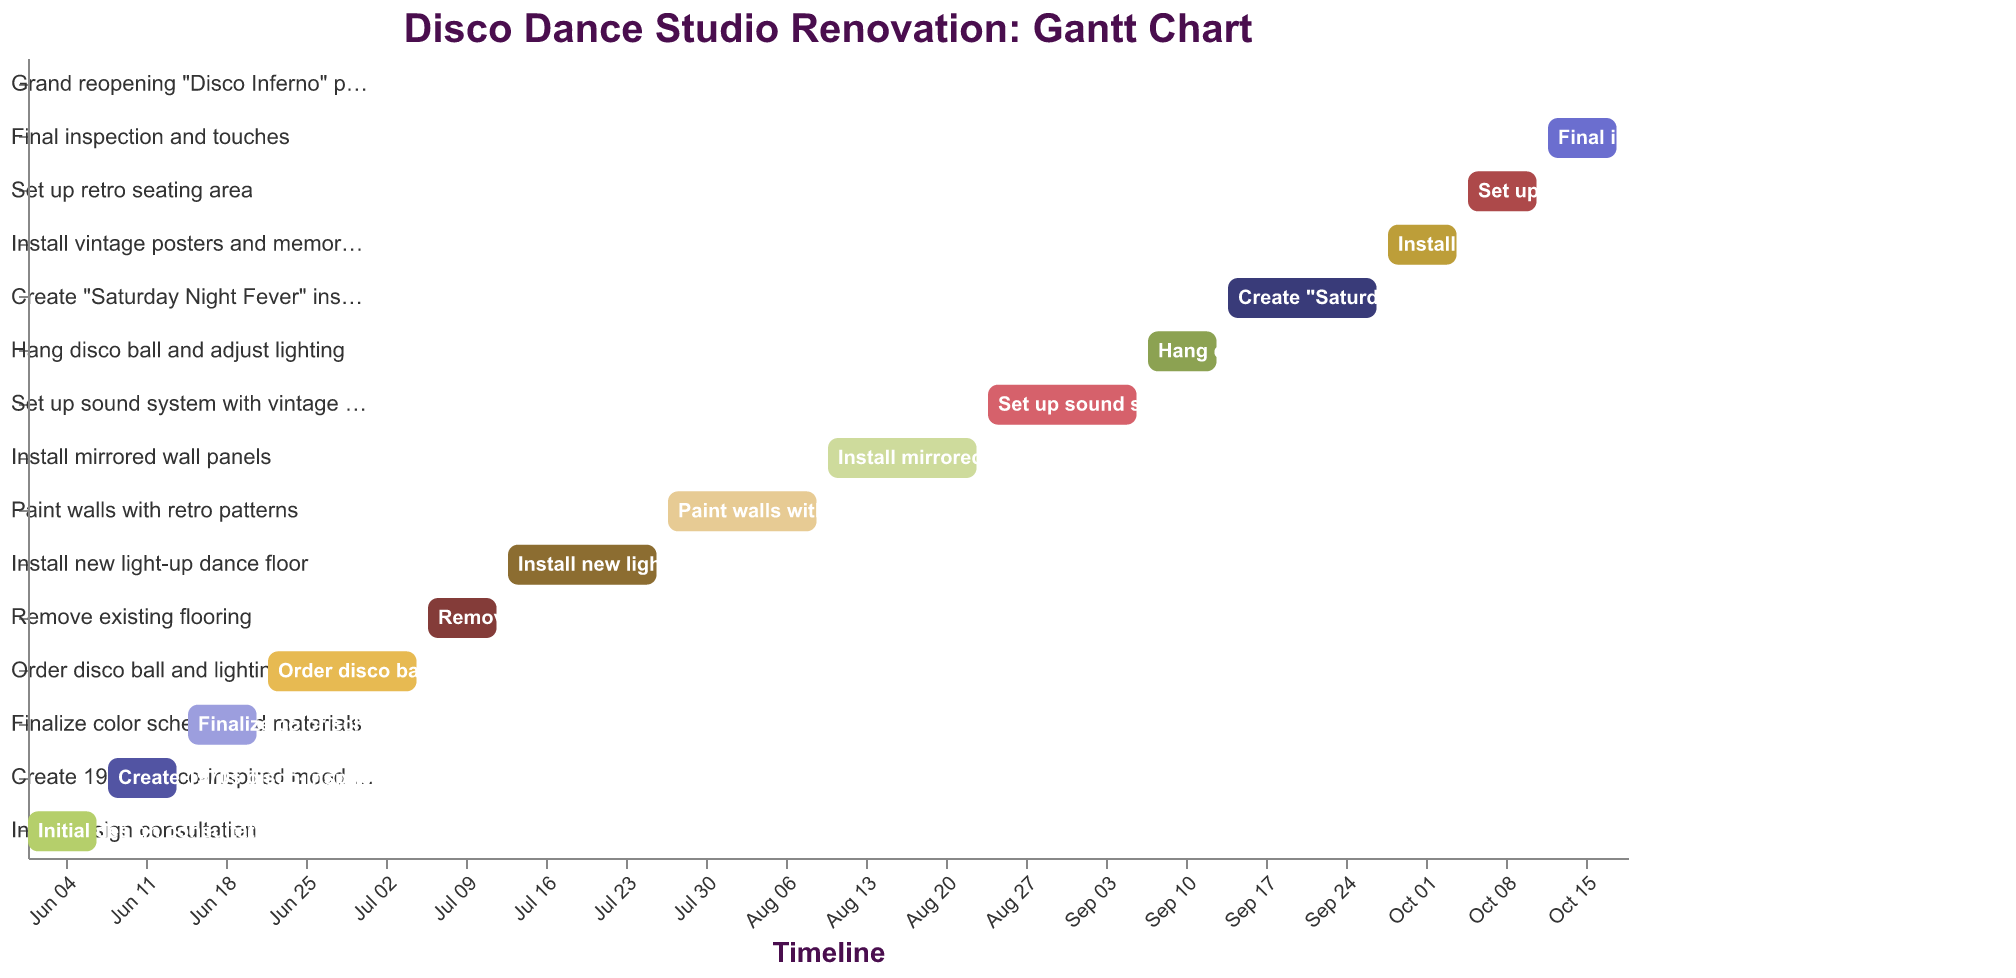What is the title of the Gantt Chart? The title is usually located at the top of the figure. In this chart, the title is prominently displayed and reads "Disco Dance Studio Renovation: Gantt Chart".
Answer: Disco Dance Studio Renovation: Gantt Chart What is the duration of the task "Install new light-up dance floor"? The duration is indicated in the "Duration (days)" column. For "Install new light-up dance floor," it is shown as 14 days.
Answer: 14 days Which task starts immediately after the "Order disco ball and lighting equipment" task? By looking at the timeline and the sequence of tasks, the next task that starts after "Order disco ball and lighting equipment" is "Remove existing flooring," which starts on 2023-07-06.
Answer: Remove existing flooring How long does the entire renovation project take, from the initial design consultation to the grand reopening party? The project starts on 2023-06-01 and ends on 2023-10-19. Counting the days between these dates, the entire project lasts 140 days.
Answer: 140 days Which task has the shortest duration? The "Grand reopening 'Disco Inferno' party" has the shortest duration of just 1 day. The start and end date for this task are the same, indicating it lasts only one day.
Answer: Grand reopening "Disco Inferno" party How many tasks have a duration of 7 days? Reviewing the duration for each task, 7 tasks have a duration of 7 days: "Initial design consultation," "Create 1970s disco-inspired mood board," "Finalize color scheme and materials," "Remove existing flooring," "Hang disco ball and adjust lighting," "Install vintage posters and memorabilia," "Set up retro seating area," and "Final inspection and touches."
Answer: 7 tasks Which tasks begin in August? Checking the tasks that start in August, we find "Install mirrored wall panels" (starting on 2023-08-10) and "Set up sound system with vintage speakers" (starting on 2023-08-24).
Answer: Install mirrored wall panels, Set up sound system with vintage speakers Which task directly follows painting walls with retro patterns? The task that directly follows "Paint walls with retro patterns" is "Install mirrored wall panels," starting on 2023-08-10.
Answer: Install mirrored wall panels Which tasks occur in July? The tasks that start in July are "Remove existing flooring" (2023-07-06), "Install new light-up dance floor" (2023-07-13), and "Paint walls with retro patterns" (2023-07-27).
Answer: Remove existing flooring, Install new light-up dance floor, Paint walls with retro patterns 